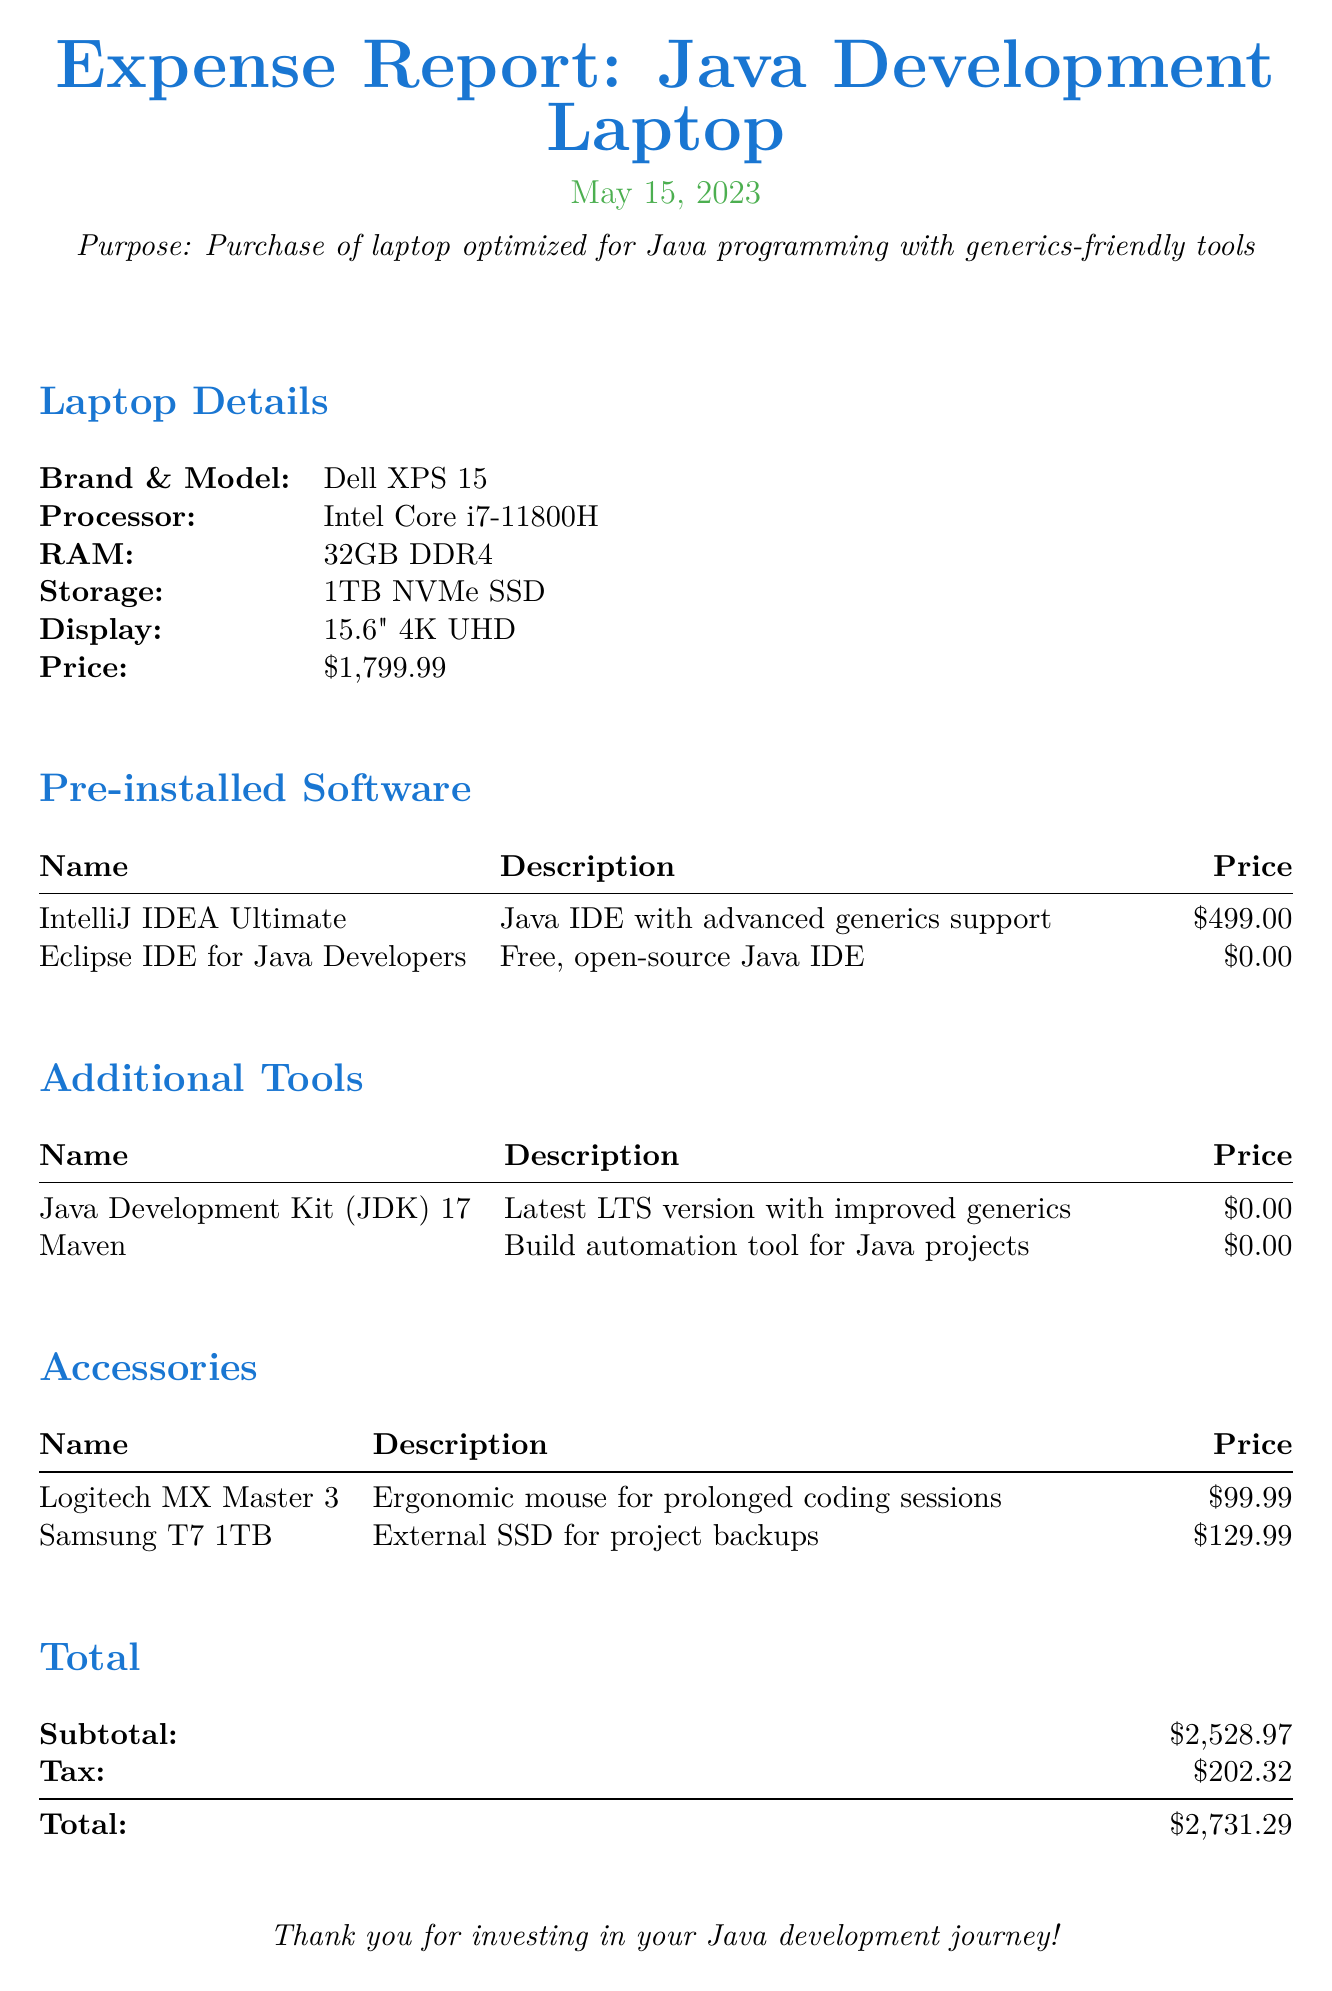What is the brand and model of the laptop? The document lists the brand and model of the laptop as Dell XPS 15.
Answer: Dell XPS 15 What is the total cost including tax? The total cost is explicitly provided in the document after accounting for the subtotal and tax.
Answer: $2,731.29 How much is the IntelliJ IDEA Ultimate license? The document specifies the cost of the IntelliJ IDEA Ultimate license as one of the pre-installed software items.
Answer: $499.00 What is the processor type of the laptop? The processor type is detailed in the laptop specifications section of the document.
Answer: Intel Core i7-11800H Which accessory is listed for prolonged coding sessions? The document mentions an accessory specifically designed for comfort during long coding sessions.
Answer: Logitech MX Master 3 How many gigabytes of RAM does the laptop have? The laptop details section provides the amount of RAM in the laptop specifications.
Answer: 32GB What is the price of the Samsung T7 external SSD? The price of the Samsung T7 is included in the accessories section of the document.
Answer: $129.99 What is the subtotal before tax for the purchase? The subtotal is provided in the total section of the document, showing the amount before tax is added.
Answer: $2,528.97 What date was the expense report created? The document includes the date when the expense report was made, which reflects the timing of the purchase.
Answer: May 15, 2023 